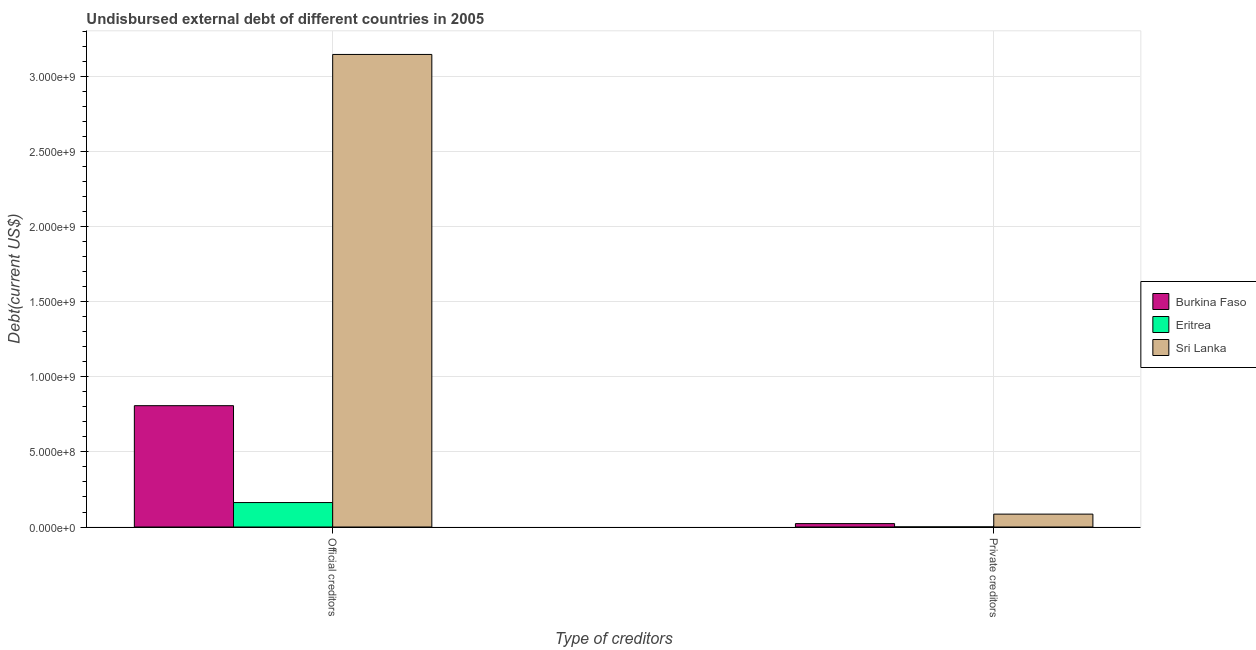How many different coloured bars are there?
Provide a succinct answer. 3. How many groups of bars are there?
Provide a short and direct response. 2. Are the number of bars on each tick of the X-axis equal?
Your answer should be compact. Yes. What is the label of the 2nd group of bars from the left?
Provide a succinct answer. Private creditors. What is the undisbursed external debt of official creditors in Eritrea?
Your answer should be very brief. 1.63e+08. Across all countries, what is the maximum undisbursed external debt of private creditors?
Keep it short and to the point. 8.59e+07. Across all countries, what is the minimum undisbursed external debt of official creditors?
Offer a terse response. 1.63e+08. In which country was the undisbursed external debt of official creditors maximum?
Keep it short and to the point. Sri Lanka. In which country was the undisbursed external debt of private creditors minimum?
Offer a terse response. Eritrea. What is the total undisbursed external debt of official creditors in the graph?
Provide a short and direct response. 4.12e+09. What is the difference between the undisbursed external debt of private creditors in Eritrea and that in Sri Lanka?
Your response must be concise. -8.52e+07. What is the difference between the undisbursed external debt of private creditors in Sri Lanka and the undisbursed external debt of official creditors in Eritrea?
Make the answer very short. -7.71e+07. What is the average undisbursed external debt of official creditors per country?
Provide a short and direct response. 1.37e+09. What is the difference between the undisbursed external debt of private creditors and undisbursed external debt of official creditors in Burkina Faso?
Your response must be concise. -7.86e+08. In how many countries, is the undisbursed external debt of private creditors greater than 2900000000 US$?
Keep it short and to the point. 0. What is the ratio of the undisbursed external debt of private creditors in Burkina Faso to that in Sri Lanka?
Ensure brevity in your answer.  0.26. Is the undisbursed external debt of official creditors in Burkina Faso less than that in Sri Lanka?
Your response must be concise. Yes. What does the 2nd bar from the left in Official creditors represents?
Offer a terse response. Eritrea. What does the 1st bar from the right in Private creditors represents?
Make the answer very short. Sri Lanka. How many bars are there?
Offer a terse response. 6. How many countries are there in the graph?
Provide a succinct answer. 3. Does the graph contain any zero values?
Make the answer very short. No. Where does the legend appear in the graph?
Your answer should be compact. Center right. How many legend labels are there?
Provide a short and direct response. 3. What is the title of the graph?
Provide a succinct answer. Undisbursed external debt of different countries in 2005. What is the label or title of the X-axis?
Your response must be concise. Type of creditors. What is the label or title of the Y-axis?
Offer a very short reply. Debt(current US$). What is the Debt(current US$) in Burkina Faso in Official creditors?
Provide a short and direct response. 8.08e+08. What is the Debt(current US$) in Eritrea in Official creditors?
Your answer should be compact. 1.63e+08. What is the Debt(current US$) of Sri Lanka in Official creditors?
Your answer should be compact. 3.15e+09. What is the Debt(current US$) of Burkina Faso in Private creditors?
Make the answer very short. 2.27e+07. What is the Debt(current US$) in Eritrea in Private creditors?
Provide a succinct answer. 6.48e+05. What is the Debt(current US$) of Sri Lanka in Private creditors?
Provide a succinct answer. 8.59e+07. Across all Type of creditors, what is the maximum Debt(current US$) of Burkina Faso?
Your response must be concise. 8.08e+08. Across all Type of creditors, what is the maximum Debt(current US$) of Eritrea?
Your answer should be compact. 1.63e+08. Across all Type of creditors, what is the maximum Debt(current US$) of Sri Lanka?
Provide a succinct answer. 3.15e+09. Across all Type of creditors, what is the minimum Debt(current US$) of Burkina Faso?
Offer a terse response. 2.27e+07. Across all Type of creditors, what is the minimum Debt(current US$) of Eritrea?
Make the answer very short. 6.48e+05. Across all Type of creditors, what is the minimum Debt(current US$) of Sri Lanka?
Make the answer very short. 8.59e+07. What is the total Debt(current US$) in Burkina Faso in the graph?
Offer a terse response. 8.31e+08. What is the total Debt(current US$) in Eritrea in the graph?
Keep it short and to the point. 1.64e+08. What is the total Debt(current US$) in Sri Lanka in the graph?
Ensure brevity in your answer.  3.23e+09. What is the difference between the Debt(current US$) in Burkina Faso in Official creditors and that in Private creditors?
Make the answer very short. 7.86e+08. What is the difference between the Debt(current US$) of Eritrea in Official creditors and that in Private creditors?
Offer a terse response. 1.62e+08. What is the difference between the Debt(current US$) of Sri Lanka in Official creditors and that in Private creditors?
Offer a very short reply. 3.06e+09. What is the difference between the Debt(current US$) in Burkina Faso in Official creditors and the Debt(current US$) in Eritrea in Private creditors?
Provide a short and direct response. 8.08e+08. What is the difference between the Debt(current US$) in Burkina Faso in Official creditors and the Debt(current US$) in Sri Lanka in Private creditors?
Give a very brief answer. 7.23e+08. What is the difference between the Debt(current US$) in Eritrea in Official creditors and the Debt(current US$) in Sri Lanka in Private creditors?
Offer a very short reply. 7.71e+07. What is the average Debt(current US$) in Burkina Faso per Type of creditors?
Ensure brevity in your answer.  4.16e+08. What is the average Debt(current US$) of Eritrea per Type of creditors?
Give a very brief answer. 8.18e+07. What is the average Debt(current US$) in Sri Lanka per Type of creditors?
Your answer should be very brief. 1.62e+09. What is the difference between the Debt(current US$) of Burkina Faso and Debt(current US$) of Eritrea in Official creditors?
Make the answer very short. 6.45e+08. What is the difference between the Debt(current US$) of Burkina Faso and Debt(current US$) of Sri Lanka in Official creditors?
Your answer should be compact. -2.34e+09. What is the difference between the Debt(current US$) of Eritrea and Debt(current US$) of Sri Lanka in Official creditors?
Provide a short and direct response. -2.99e+09. What is the difference between the Debt(current US$) in Burkina Faso and Debt(current US$) in Eritrea in Private creditors?
Offer a very short reply. 2.21e+07. What is the difference between the Debt(current US$) in Burkina Faso and Debt(current US$) in Sri Lanka in Private creditors?
Your answer should be compact. -6.32e+07. What is the difference between the Debt(current US$) in Eritrea and Debt(current US$) in Sri Lanka in Private creditors?
Offer a very short reply. -8.52e+07. What is the ratio of the Debt(current US$) in Burkina Faso in Official creditors to that in Private creditors?
Make the answer very short. 35.59. What is the ratio of the Debt(current US$) of Eritrea in Official creditors to that in Private creditors?
Make the answer very short. 251.51. What is the ratio of the Debt(current US$) in Sri Lanka in Official creditors to that in Private creditors?
Your response must be concise. 36.67. What is the difference between the highest and the second highest Debt(current US$) in Burkina Faso?
Give a very brief answer. 7.86e+08. What is the difference between the highest and the second highest Debt(current US$) of Eritrea?
Provide a succinct answer. 1.62e+08. What is the difference between the highest and the second highest Debt(current US$) of Sri Lanka?
Your response must be concise. 3.06e+09. What is the difference between the highest and the lowest Debt(current US$) of Burkina Faso?
Your answer should be very brief. 7.86e+08. What is the difference between the highest and the lowest Debt(current US$) in Eritrea?
Make the answer very short. 1.62e+08. What is the difference between the highest and the lowest Debt(current US$) in Sri Lanka?
Offer a very short reply. 3.06e+09. 